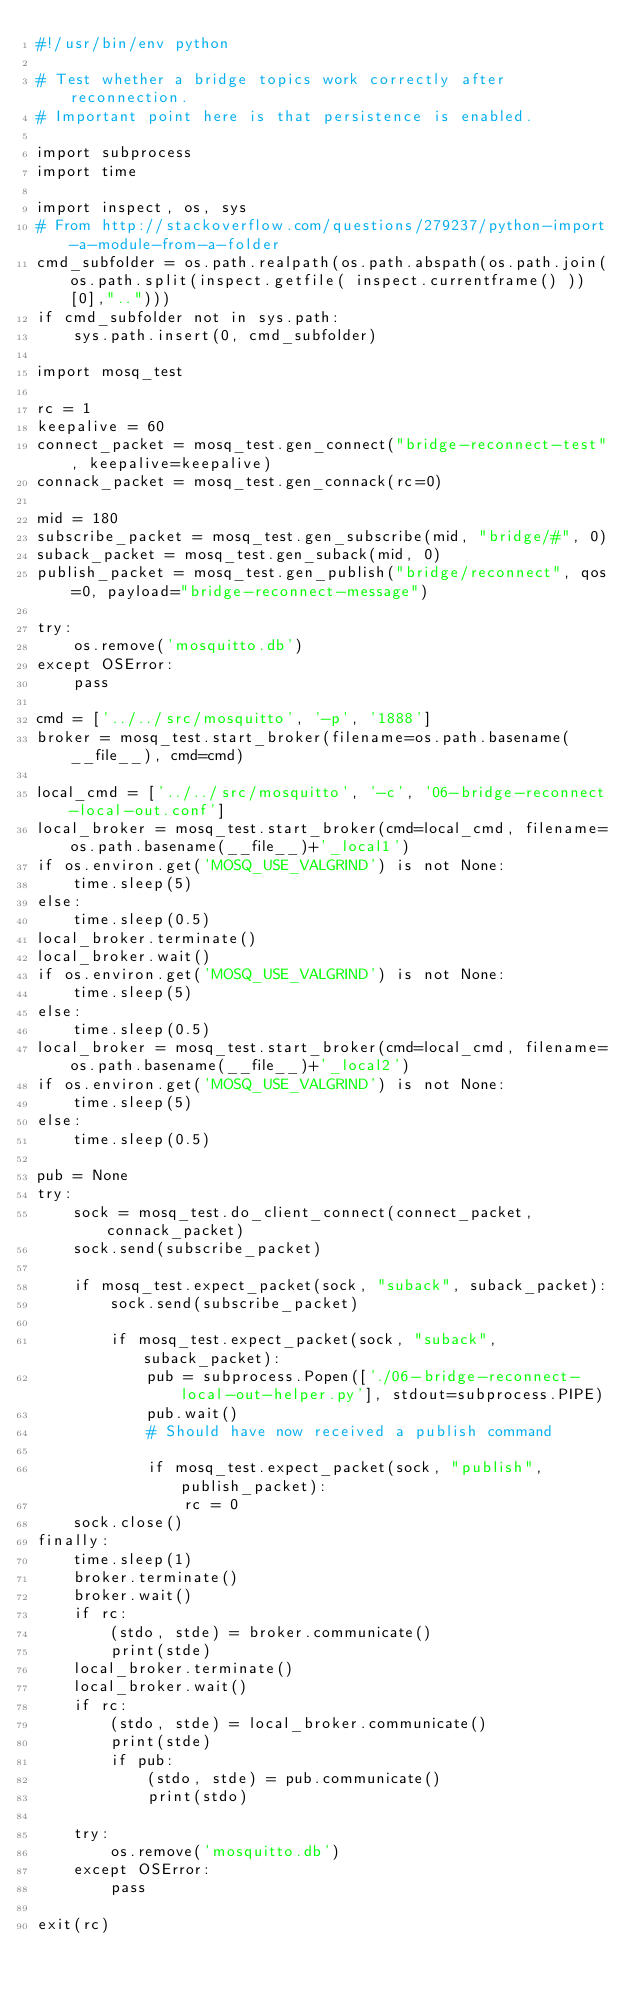<code> <loc_0><loc_0><loc_500><loc_500><_Python_>#!/usr/bin/env python

# Test whether a bridge topics work correctly after reconnection.
# Important point here is that persistence is enabled.

import subprocess
import time

import inspect, os, sys
# From http://stackoverflow.com/questions/279237/python-import-a-module-from-a-folder
cmd_subfolder = os.path.realpath(os.path.abspath(os.path.join(os.path.split(inspect.getfile( inspect.currentframe() ))[0],"..")))
if cmd_subfolder not in sys.path:
    sys.path.insert(0, cmd_subfolder)

import mosq_test

rc = 1
keepalive = 60
connect_packet = mosq_test.gen_connect("bridge-reconnect-test", keepalive=keepalive)
connack_packet = mosq_test.gen_connack(rc=0)

mid = 180
subscribe_packet = mosq_test.gen_subscribe(mid, "bridge/#", 0)
suback_packet = mosq_test.gen_suback(mid, 0)
publish_packet = mosq_test.gen_publish("bridge/reconnect", qos=0, payload="bridge-reconnect-message")

try:
    os.remove('mosquitto.db')
except OSError:
    pass

cmd = ['../../src/mosquitto', '-p', '1888']
broker = mosq_test.start_broker(filename=os.path.basename(__file__), cmd=cmd)

local_cmd = ['../../src/mosquitto', '-c', '06-bridge-reconnect-local-out.conf']
local_broker = mosq_test.start_broker(cmd=local_cmd, filename=os.path.basename(__file__)+'_local1')
if os.environ.get('MOSQ_USE_VALGRIND') is not None:
    time.sleep(5)
else:
    time.sleep(0.5)
local_broker.terminate()
local_broker.wait()
if os.environ.get('MOSQ_USE_VALGRIND') is not None:
    time.sleep(5)
else:
    time.sleep(0.5)
local_broker = mosq_test.start_broker(cmd=local_cmd, filename=os.path.basename(__file__)+'_local2')
if os.environ.get('MOSQ_USE_VALGRIND') is not None:
    time.sleep(5)
else:
    time.sleep(0.5)

pub = None
try:
    sock = mosq_test.do_client_connect(connect_packet, connack_packet)
    sock.send(subscribe_packet)

    if mosq_test.expect_packet(sock, "suback", suback_packet):
        sock.send(subscribe_packet)

        if mosq_test.expect_packet(sock, "suback", suback_packet):
            pub = subprocess.Popen(['./06-bridge-reconnect-local-out-helper.py'], stdout=subprocess.PIPE)
            pub.wait()
            # Should have now received a publish command

            if mosq_test.expect_packet(sock, "publish", publish_packet):
                rc = 0
    sock.close()
finally:
    time.sleep(1)
    broker.terminate()
    broker.wait()
    if rc:
        (stdo, stde) = broker.communicate()
        print(stde)
    local_broker.terminate()
    local_broker.wait()
    if rc:
        (stdo, stde) = local_broker.communicate()
        print(stde)
        if pub:
            (stdo, stde) = pub.communicate()
            print(stdo)

    try:
        os.remove('mosquitto.db')
    except OSError:
        pass

exit(rc)

</code> 